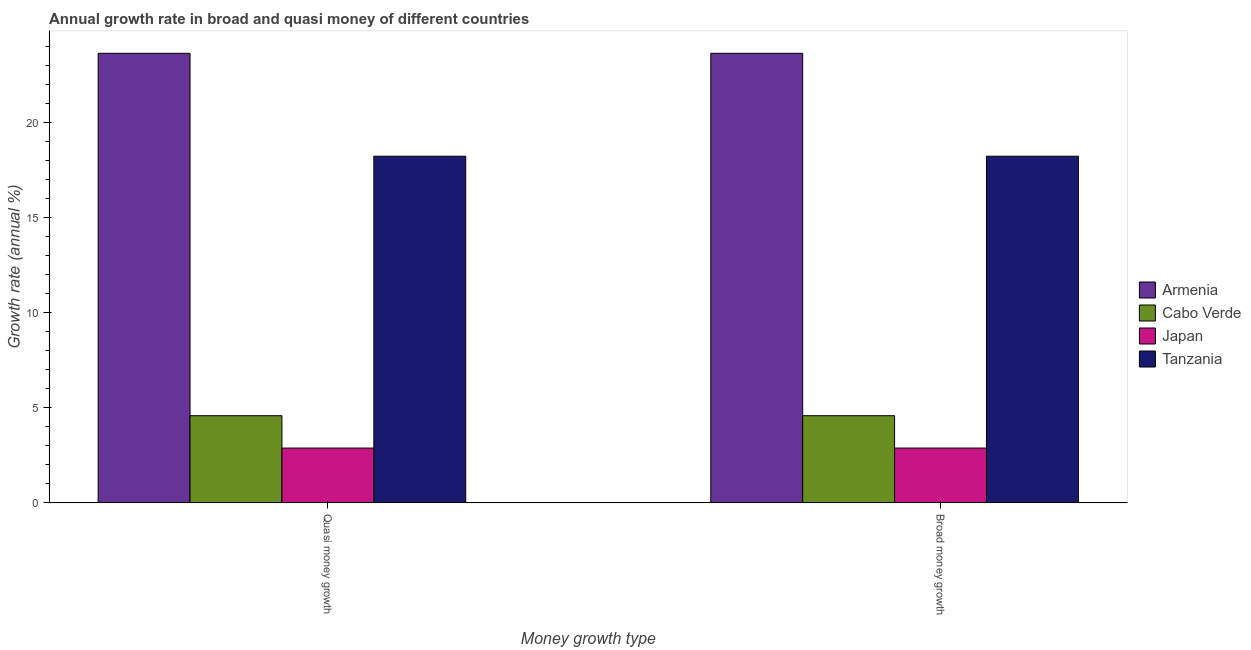How many different coloured bars are there?
Your response must be concise. 4. How many groups of bars are there?
Offer a very short reply. 2. Are the number of bars per tick equal to the number of legend labels?
Your answer should be compact. Yes. How many bars are there on the 1st tick from the right?
Provide a short and direct response. 4. What is the label of the 1st group of bars from the left?
Give a very brief answer. Quasi money growth. What is the annual growth rate in quasi money in Tanzania?
Give a very brief answer. 18.24. Across all countries, what is the maximum annual growth rate in quasi money?
Provide a succinct answer. 23.66. Across all countries, what is the minimum annual growth rate in broad money?
Ensure brevity in your answer.  2.88. In which country was the annual growth rate in quasi money maximum?
Keep it short and to the point. Armenia. What is the total annual growth rate in broad money in the graph?
Make the answer very short. 49.36. What is the difference between the annual growth rate in quasi money in Japan and that in Armenia?
Offer a very short reply. -20.77. What is the difference between the annual growth rate in broad money in Japan and the annual growth rate in quasi money in Tanzania?
Provide a short and direct response. -15.36. What is the average annual growth rate in broad money per country?
Your answer should be very brief. 12.34. What is the difference between the annual growth rate in quasi money and annual growth rate in broad money in Japan?
Give a very brief answer. 0. In how many countries, is the annual growth rate in broad money greater than 14 %?
Make the answer very short. 2. What is the ratio of the annual growth rate in quasi money in Japan to that in Tanzania?
Make the answer very short. 0.16. In how many countries, is the annual growth rate in broad money greater than the average annual growth rate in broad money taken over all countries?
Offer a very short reply. 2. What does the 3rd bar from the left in Broad money growth represents?
Your response must be concise. Japan. Are all the bars in the graph horizontal?
Offer a terse response. No. How many countries are there in the graph?
Ensure brevity in your answer.  4. What is the difference between two consecutive major ticks on the Y-axis?
Provide a short and direct response. 5. Does the graph contain any zero values?
Offer a very short reply. No. Does the graph contain grids?
Your answer should be compact. No. Where does the legend appear in the graph?
Ensure brevity in your answer.  Center right. How are the legend labels stacked?
Offer a very short reply. Vertical. What is the title of the graph?
Give a very brief answer. Annual growth rate in broad and quasi money of different countries. What is the label or title of the X-axis?
Offer a terse response. Money growth type. What is the label or title of the Y-axis?
Offer a terse response. Growth rate (annual %). What is the Growth rate (annual %) of Armenia in Quasi money growth?
Provide a short and direct response. 23.66. What is the Growth rate (annual %) in Cabo Verde in Quasi money growth?
Provide a succinct answer. 4.58. What is the Growth rate (annual %) in Japan in Quasi money growth?
Provide a short and direct response. 2.88. What is the Growth rate (annual %) in Tanzania in Quasi money growth?
Offer a terse response. 18.24. What is the Growth rate (annual %) in Armenia in Broad money growth?
Your answer should be very brief. 23.66. What is the Growth rate (annual %) of Cabo Verde in Broad money growth?
Your response must be concise. 4.58. What is the Growth rate (annual %) of Japan in Broad money growth?
Provide a short and direct response. 2.88. What is the Growth rate (annual %) of Tanzania in Broad money growth?
Make the answer very short. 18.24. Across all Money growth type, what is the maximum Growth rate (annual %) in Armenia?
Your answer should be very brief. 23.66. Across all Money growth type, what is the maximum Growth rate (annual %) in Cabo Verde?
Offer a terse response. 4.58. Across all Money growth type, what is the maximum Growth rate (annual %) in Japan?
Your answer should be very brief. 2.88. Across all Money growth type, what is the maximum Growth rate (annual %) of Tanzania?
Your response must be concise. 18.24. Across all Money growth type, what is the minimum Growth rate (annual %) of Armenia?
Provide a succinct answer. 23.66. Across all Money growth type, what is the minimum Growth rate (annual %) of Cabo Verde?
Offer a very short reply. 4.58. Across all Money growth type, what is the minimum Growth rate (annual %) of Japan?
Your response must be concise. 2.88. Across all Money growth type, what is the minimum Growth rate (annual %) of Tanzania?
Keep it short and to the point. 18.24. What is the total Growth rate (annual %) in Armenia in the graph?
Keep it short and to the point. 47.31. What is the total Growth rate (annual %) of Cabo Verde in the graph?
Your response must be concise. 9.17. What is the total Growth rate (annual %) of Japan in the graph?
Offer a terse response. 5.76. What is the total Growth rate (annual %) of Tanzania in the graph?
Your response must be concise. 36.48. What is the difference between the Growth rate (annual %) of Armenia in Quasi money growth and that in Broad money growth?
Offer a very short reply. 0. What is the difference between the Growth rate (annual %) of Japan in Quasi money growth and that in Broad money growth?
Ensure brevity in your answer.  0. What is the difference between the Growth rate (annual %) in Tanzania in Quasi money growth and that in Broad money growth?
Give a very brief answer. 0. What is the difference between the Growth rate (annual %) of Armenia in Quasi money growth and the Growth rate (annual %) of Cabo Verde in Broad money growth?
Offer a very short reply. 19.07. What is the difference between the Growth rate (annual %) in Armenia in Quasi money growth and the Growth rate (annual %) in Japan in Broad money growth?
Give a very brief answer. 20.77. What is the difference between the Growth rate (annual %) in Armenia in Quasi money growth and the Growth rate (annual %) in Tanzania in Broad money growth?
Provide a succinct answer. 5.42. What is the difference between the Growth rate (annual %) in Cabo Verde in Quasi money growth and the Growth rate (annual %) in Japan in Broad money growth?
Your answer should be compact. 1.7. What is the difference between the Growth rate (annual %) of Cabo Verde in Quasi money growth and the Growth rate (annual %) of Tanzania in Broad money growth?
Your answer should be very brief. -13.65. What is the difference between the Growth rate (annual %) of Japan in Quasi money growth and the Growth rate (annual %) of Tanzania in Broad money growth?
Provide a short and direct response. -15.36. What is the average Growth rate (annual %) of Armenia per Money growth type?
Make the answer very short. 23.66. What is the average Growth rate (annual %) of Cabo Verde per Money growth type?
Keep it short and to the point. 4.58. What is the average Growth rate (annual %) of Japan per Money growth type?
Offer a terse response. 2.88. What is the average Growth rate (annual %) of Tanzania per Money growth type?
Your response must be concise. 18.24. What is the difference between the Growth rate (annual %) of Armenia and Growth rate (annual %) of Cabo Verde in Quasi money growth?
Give a very brief answer. 19.07. What is the difference between the Growth rate (annual %) of Armenia and Growth rate (annual %) of Japan in Quasi money growth?
Keep it short and to the point. 20.77. What is the difference between the Growth rate (annual %) of Armenia and Growth rate (annual %) of Tanzania in Quasi money growth?
Provide a succinct answer. 5.42. What is the difference between the Growth rate (annual %) of Cabo Verde and Growth rate (annual %) of Japan in Quasi money growth?
Keep it short and to the point. 1.7. What is the difference between the Growth rate (annual %) of Cabo Verde and Growth rate (annual %) of Tanzania in Quasi money growth?
Keep it short and to the point. -13.65. What is the difference between the Growth rate (annual %) of Japan and Growth rate (annual %) of Tanzania in Quasi money growth?
Your answer should be compact. -15.36. What is the difference between the Growth rate (annual %) of Armenia and Growth rate (annual %) of Cabo Verde in Broad money growth?
Make the answer very short. 19.07. What is the difference between the Growth rate (annual %) of Armenia and Growth rate (annual %) of Japan in Broad money growth?
Make the answer very short. 20.77. What is the difference between the Growth rate (annual %) in Armenia and Growth rate (annual %) in Tanzania in Broad money growth?
Make the answer very short. 5.42. What is the difference between the Growth rate (annual %) of Cabo Verde and Growth rate (annual %) of Japan in Broad money growth?
Offer a terse response. 1.7. What is the difference between the Growth rate (annual %) in Cabo Verde and Growth rate (annual %) in Tanzania in Broad money growth?
Provide a short and direct response. -13.65. What is the difference between the Growth rate (annual %) of Japan and Growth rate (annual %) of Tanzania in Broad money growth?
Make the answer very short. -15.36. What is the ratio of the Growth rate (annual %) in Cabo Verde in Quasi money growth to that in Broad money growth?
Make the answer very short. 1. What is the ratio of the Growth rate (annual %) of Japan in Quasi money growth to that in Broad money growth?
Ensure brevity in your answer.  1. What is the ratio of the Growth rate (annual %) in Tanzania in Quasi money growth to that in Broad money growth?
Offer a very short reply. 1. What is the difference between the highest and the second highest Growth rate (annual %) in Armenia?
Provide a short and direct response. 0. What is the difference between the highest and the second highest Growth rate (annual %) in Cabo Verde?
Your response must be concise. 0. What is the difference between the highest and the second highest Growth rate (annual %) in Japan?
Keep it short and to the point. 0. What is the difference between the highest and the lowest Growth rate (annual %) in Armenia?
Provide a succinct answer. 0. What is the difference between the highest and the lowest Growth rate (annual %) in Tanzania?
Offer a very short reply. 0. 